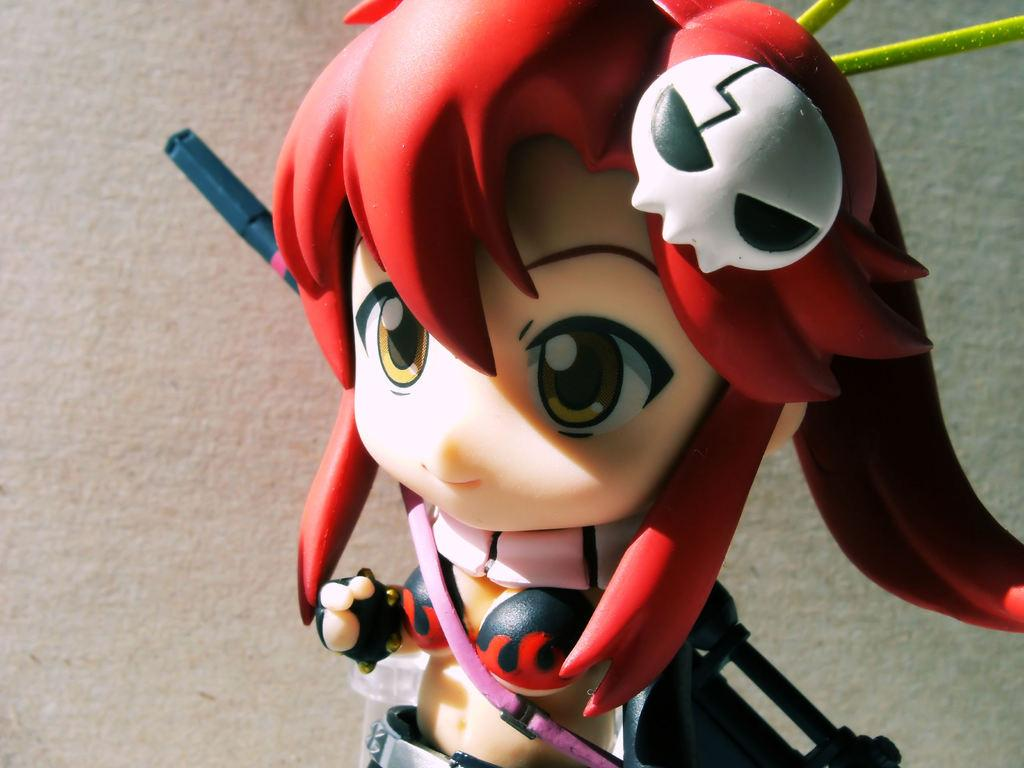What is the main subject in the center of the image? There is a toy in the center of the image. What can be seen at the bottom of the image? There is a wall at the bottom of the image. What letter is written on the toy in the image? There is no letter written on the toy in the image. Is there a cap visible on the toy in the image? There is no cap visible on the toy in the image. 